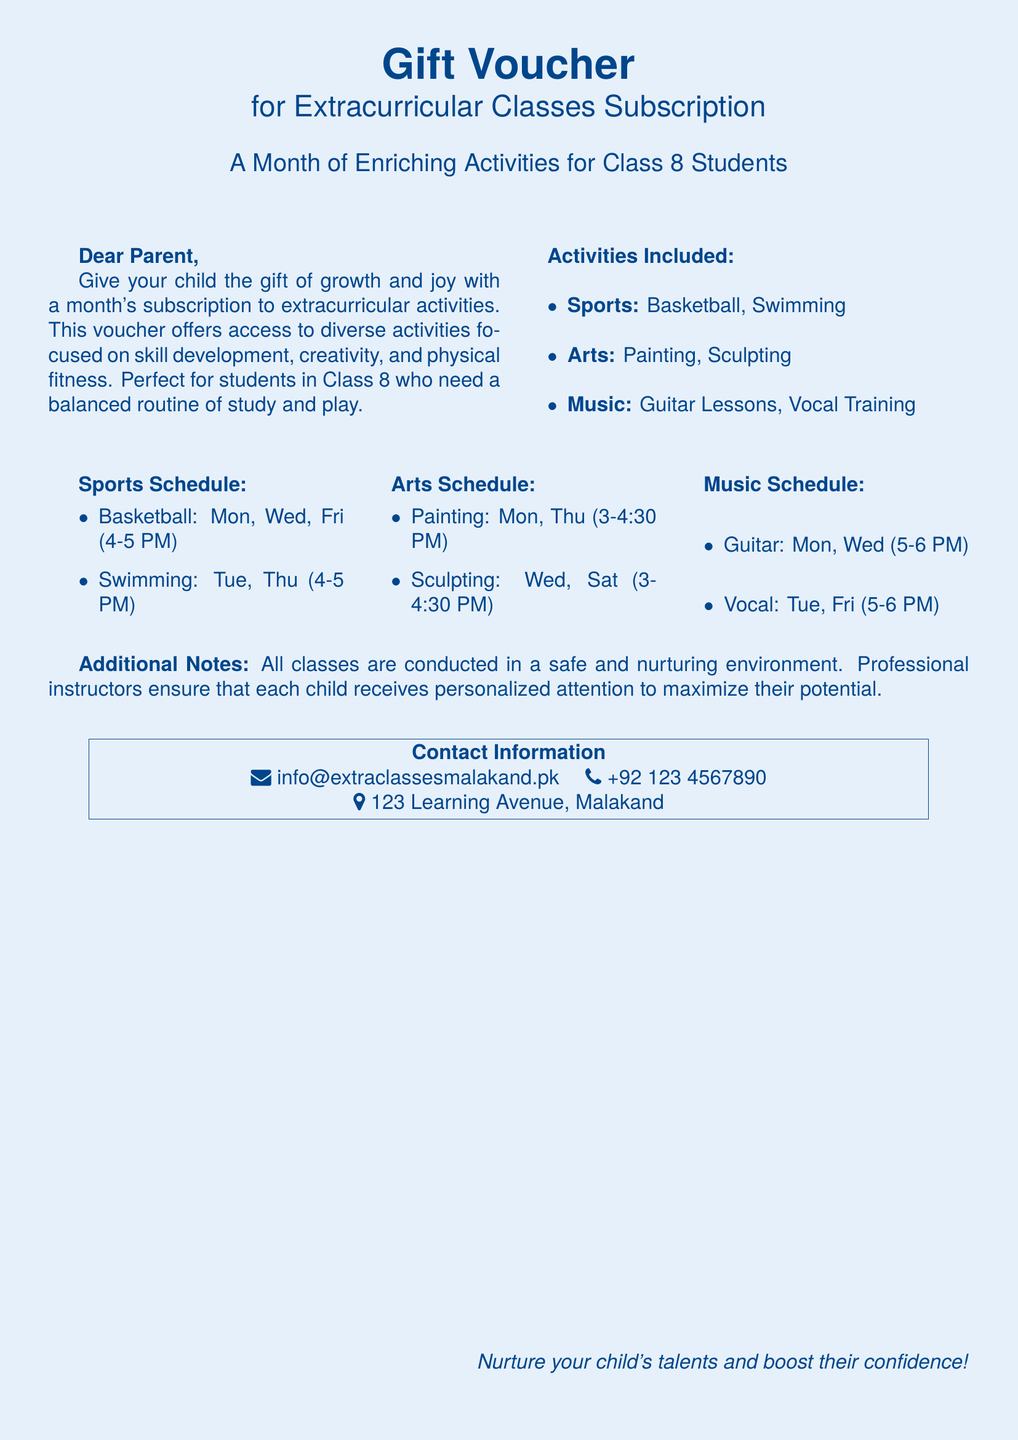What types of activities are included? The document lists specific activities such as Sports, Arts, and Music, which are part of the subscription.
Answer: Sports, Arts, Music What is the swimming schedule? The swimming classes are scheduled for Tuesday and Thursday from 4-5 PM, as mentioned in the document.
Answer: Tuesday, Thursday (4-5 PM) How many classes are there for painting? The painting class is scheduled for two days a week as noted in the document.
Answer: Two Who can participate in these classes? The voucher emphasizes that it is intended for students in Class 8, which is stated in the introduction.
Answer: Class 8 students What is the contact email provided? The document lists the email for inquiries, specifically mentioning info@extraclassesmalakand.pk.
Answer: info@extraclassesmalakand.pk What day is the vocal training class held? The document specifies that vocal training occurs on Tuesday and Friday, indicating the relevant days.
Answer: Tuesday, Friday How does the document characterize the class environment? The document states that all classes are conducted in a safe and nurturing environment, emphasizing the caring aspect of the learning space.
Answer: Safe and nurturing environment What kind of professional support is mentioned? The document mentions that professional instructors ensure personalized attention for each child, detailing the level of support provided.
Answer: Professional instructors 